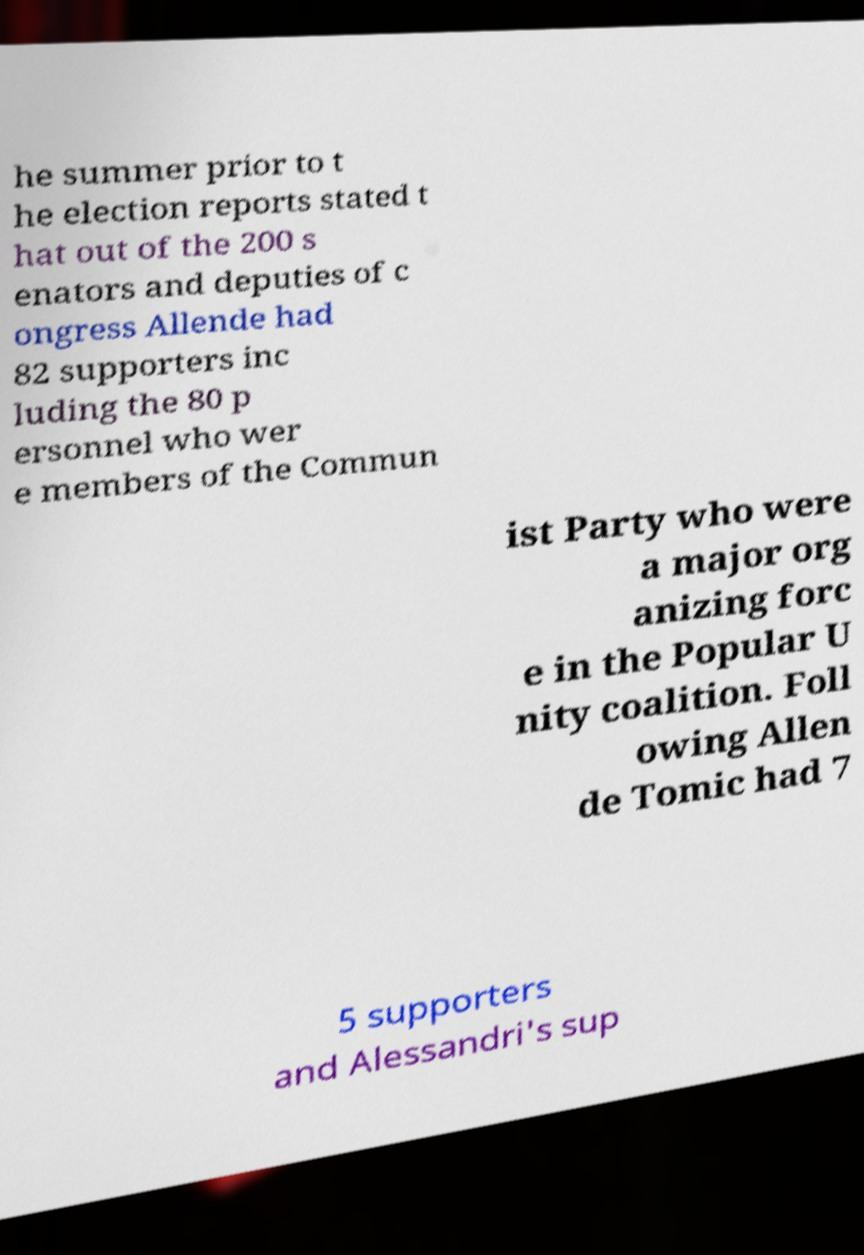I need the written content from this picture converted into text. Can you do that? he summer prior to t he election reports stated t hat out of the 200 s enators and deputies of c ongress Allende had 82 supporters inc luding the 80 p ersonnel who wer e members of the Commun ist Party who were a major org anizing forc e in the Popular U nity coalition. Foll owing Allen de Tomic had 7 5 supporters and Alessandri's sup 